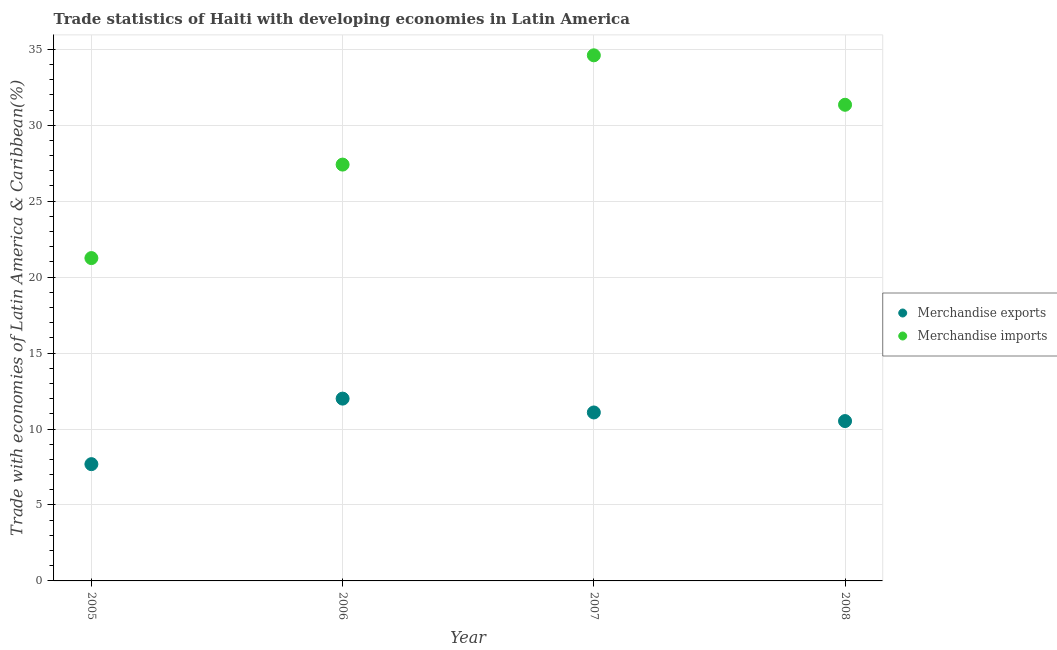How many different coloured dotlines are there?
Your response must be concise. 2. Is the number of dotlines equal to the number of legend labels?
Give a very brief answer. Yes. What is the merchandise exports in 2008?
Ensure brevity in your answer.  10.52. Across all years, what is the maximum merchandise imports?
Give a very brief answer. 34.6. Across all years, what is the minimum merchandise exports?
Provide a short and direct response. 7.69. In which year was the merchandise exports maximum?
Your answer should be compact. 2006. What is the total merchandise imports in the graph?
Your answer should be compact. 114.6. What is the difference between the merchandise exports in 2005 and that in 2007?
Make the answer very short. -3.4. What is the difference between the merchandise imports in 2007 and the merchandise exports in 2005?
Offer a very short reply. 26.91. What is the average merchandise exports per year?
Provide a short and direct response. 10.33. In the year 2008, what is the difference between the merchandise imports and merchandise exports?
Your answer should be very brief. 20.82. In how many years, is the merchandise exports greater than 9 %?
Keep it short and to the point. 3. What is the ratio of the merchandise imports in 2007 to that in 2008?
Your answer should be very brief. 1.1. Is the merchandise imports in 2005 less than that in 2007?
Your answer should be compact. Yes. Is the difference between the merchandise exports in 2005 and 2008 greater than the difference between the merchandise imports in 2005 and 2008?
Make the answer very short. Yes. What is the difference between the highest and the second highest merchandise imports?
Provide a short and direct response. 3.26. What is the difference between the highest and the lowest merchandise exports?
Offer a very short reply. 4.31. Is the sum of the merchandise exports in 2005 and 2008 greater than the maximum merchandise imports across all years?
Offer a very short reply. No. Does the merchandise imports monotonically increase over the years?
Provide a succinct answer. No. Is the merchandise exports strictly greater than the merchandise imports over the years?
Ensure brevity in your answer.  No. How many dotlines are there?
Make the answer very short. 2. Does the graph contain any zero values?
Ensure brevity in your answer.  No. Where does the legend appear in the graph?
Offer a terse response. Center right. How many legend labels are there?
Your answer should be very brief. 2. What is the title of the graph?
Offer a terse response. Trade statistics of Haiti with developing economies in Latin America. What is the label or title of the Y-axis?
Offer a terse response. Trade with economies of Latin America & Caribbean(%). What is the Trade with economies of Latin America & Caribbean(%) in Merchandise exports in 2005?
Give a very brief answer. 7.69. What is the Trade with economies of Latin America & Caribbean(%) in Merchandise imports in 2005?
Ensure brevity in your answer.  21.25. What is the Trade with economies of Latin America & Caribbean(%) of Merchandise exports in 2006?
Provide a short and direct response. 12. What is the Trade with economies of Latin America & Caribbean(%) of Merchandise imports in 2006?
Offer a terse response. 27.41. What is the Trade with economies of Latin America & Caribbean(%) in Merchandise exports in 2007?
Keep it short and to the point. 11.09. What is the Trade with economies of Latin America & Caribbean(%) of Merchandise imports in 2007?
Give a very brief answer. 34.6. What is the Trade with economies of Latin America & Caribbean(%) in Merchandise exports in 2008?
Provide a short and direct response. 10.52. What is the Trade with economies of Latin America & Caribbean(%) of Merchandise imports in 2008?
Make the answer very short. 31.34. Across all years, what is the maximum Trade with economies of Latin America & Caribbean(%) in Merchandise exports?
Keep it short and to the point. 12. Across all years, what is the maximum Trade with economies of Latin America & Caribbean(%) of Merchandise imports?
Ensure brevity in your answer.  34.6. Across all years, what is the minimum Trade with economies of Latin America & Caribbean(%) of Merchandise exports?
Keep it short and to the point. 7.69. Across all years, what is the minimum Trade with economies of Latin America & Caribbean(%) in Merchandise imports?
Your response must be concise. 21.25. What is the total Trade with economies of Latin America & Caribbean(%) in Merchandise exports in the graph?
Provide a succinct answer. 41.3. What is the total Trade with economies of Latin America & Caribbean(%) in Merchandise imports in the graph?
Give a very brief answer. 114.6. What is the difference between the Trade with economies of Latin America & Caribbean(%) in Merchandise exports in 2005 and that in 2006?
Provide a succinct answer. -4.31. What is the difference between the Trade with economies of Latin America & Caribbean(%) in Merchandise imports in 2005 and that in 2006?
Provide a succinct answer. -6.15. What is the difference between the Trade with economies of Latin America & Caribbean(%) of Merchandise exports in 2005 and that in 2007?
Your answer should be very brief. -3.4. What is the difference between the Trade with economies of Latin America & Caribbean(%) in Merchandise imports in 2005 and that in 2007?
Give a very brief answer. -13.35. What is the difference between the Trade with economies of Latin America & Caribbean(%) in Merchandise exports in 2005 and that in 2008?
Offer a very short reply. -2.84. What is the difference between the Trade with economies of Latin America & Caribbean(%) of Merchandise imports in 2005 and that in 2008?
Give a very brief answer. -10.09. What is the difference between the Trade with economies of Latin America & Caribbean(%) of Merchandise exports in 2006 and that in 2007?
Give a very brief answer. 0.91. What is the difference between the Trade with economies of Latin America & Caribbean(%) in Merchandise imports in 2006 and that in 2007?
Give a very brief answer. -7.19. What is the difference between the Trade with economies of Latin America & Caribbean(%) of Merchandise exports in 2006 and that in 2008?
Your response must be concise. 1.48. What is the difference between the Trade with economies of Latin America & Caribbean(%) in Merchandise imports in 2006 and that in 2008?
Keep it short and to the point. -3.94. What is the difference between the Trade with economies of Latin America & Caribbean(%) of Merchandise exports in 2007 and that in 2008?
Make the answer very short. 0.57. What is the difference between the Trade with economies of Latin America & Caribbean(%) of Merchandise imports in 2007 and that in 2008?
Provide a succinct answer. 3.26. What is the difference between the Trade with economies of Latin America & Caribbean(%) in Merchandise exports in 2005 and the Trade with economies of Latin America & Caribbean(%) in Merchandise imports in 2006?
Make the answer very short. -19.72. What is the difference between the Trade with economies of Latin America & Caribbean(%) of Merchandise exports in 2005 and the Trade with economies of Latin America & Caribbean(%) of Merchandise imports in 2007?
Offer a very short reply. -26.91. What is the difference between the Trade with economies of Latin America & Caribbean(%) in Merchandise exports in 2005 and the Trade with economies of Latin America & Caribbean(%) in Merchandise imports in 2008?
Give a very brief answer. -23.66. What is the difference between the Trade with economies of Latin America & Caribbean(%) in Merchandise exports in 2006 and the Trade with economies of Latin America & Caribbean(%) in Merchandise imports in 2007?
Make the answer very short. -22.6. What is the difference between the Trade with economies of Latin America & Caribbean(%) of Merchandise exports in 2006 and the Trade with economies of Latin America & Caribbean(%) of Merchandise imports in 2008?
Give a very brief answer. -19.34. What is the difference between the Trade with economies of Latin America & Caribbean(%) of Merchandise exports in 2007 and the Trade with economies of Latin America & Caribbean(%) of Merchandise imports in 2008?
Make the answer very short. -20.25. What is the average Trade with economies of Latin America & Caribbean(%) in Merchandise exports per year?
Offer a very short reply. 10.33. What is the average Trade with economies of Latin America & Caribbean(%) in Merchandise imports per year?
Your response must be concise. 28.65. In the year 2005, what is the difference between the Trade with economies of Latin America & Caribbean(%) in Merchandise exports and Trade with economies of Latin America & Caribbean(%) in Merchandise imports?
Make the answer very short. -13.57. In the year 2006, what is the difference between the Trade with economies of Latin America & Caribbean(%) in Merchandise exports and Trade with economies of Latin America & Caribbean(%) in Merchandise imports?
Make the answer very short. -15.41. In the year 2007, what is the difference between the Trade with economies of Latin America & Caribbean(%) of Merchandise exports and Trade with economies of Latin America & Caribbean(%) of Merchandise imports?
Your response must be concise. -23.51. In the year 2008, what is the difference between the Trade with economies of Latin America & Caribbean(%) in Merchandise exports and Trade with economies of Latin America & Caribbean(%) in Merchandise imports?
Ensure brevity in your answer.  -20.82. What is the ratio of the Trade with economies of Latin America & Caribbean(%) of Merchandise exports in 2005 to that in 2006?
Offer a very short reply. 0.64. What is the ratio of the Trade with economies of Latin America & Caribbean(%) of Merchandise imports in 2005 to that in 2006?
Give a very brief answer. 0.78. What is the ratio of the Trade with economies of Latin America & Caribbean(%) of Merchandise exports in 2005 to that in 2007?
Provide a succinct answer. 0.69. What is the ratio of the Trade with economies of Latin America & Caribbean(%) of Merchandise imports in 2005 to that in 2007?
Offer a terse response. 0.61. What is the ratio of the Trade with economies of Latin America & Caribbean(%) of Merchandise exports in 2005 to that in 2008?
Make the answer very short. 0.73. What is the ratio of the Trade with economies of Latin America & Caribbean(%) of Merchandise imports in 2005 to that in 2008?
Give a very brief answer. 0.68. What is the ratio of the Trade with economies of Latin America & Caribbean(%) in Merchandise exports in 2006 to that in 2007?
Provide a succinct answer. 1.08. What is the ratio of the Trade with economies of Latin America & Caribbean(%) in Merchandise imports in 2006 to that in 2007?
Provide a succinct answer. 0.79. What is the ratio of the Trade with economies of Latin America & Caribbean(%) of Merchandise exports in 2006 to that in 2008?
Provide a succinct answer. 1.14. What is the ratio of the Trade with economies of Latin America & Caribbean(%) of Merchandise imports in 2006 to that in 2008?
Offer a very short reply. 0.87. What is the ratio of the Trade with economies of Latin America & Caribbean(%) in Merchandise exports in 2007 to that in 2008?
Your response must be concise. 1.05. What is the ratio of the Trade with economies of Latin America & Caribbean(%) in Merchandise imports in 2007 to that in 2008?
Your response must be concise. 1.1. What is the difference between the highest and the second highest Trade with economies of Latin America & Caribbean(%) in Merchandise exports?
Your response must be concise. 0.91. What is the difference between the highest and the second highest Trade with economies of Latin America & Caribbean(%) in Merchandise imports?
Offer a terse response. 3.26. What is the difference between the highest and the lowest Trade with economies of Latin America & Caribbean(%) of Merchandise exports?
Make the answer very short. 4.31. What is the difference between the highest and the lowest Trade with economies of Latin America & Caribbean(%) in Merchandise imports?
Provide a succinct answer. 13.35. 